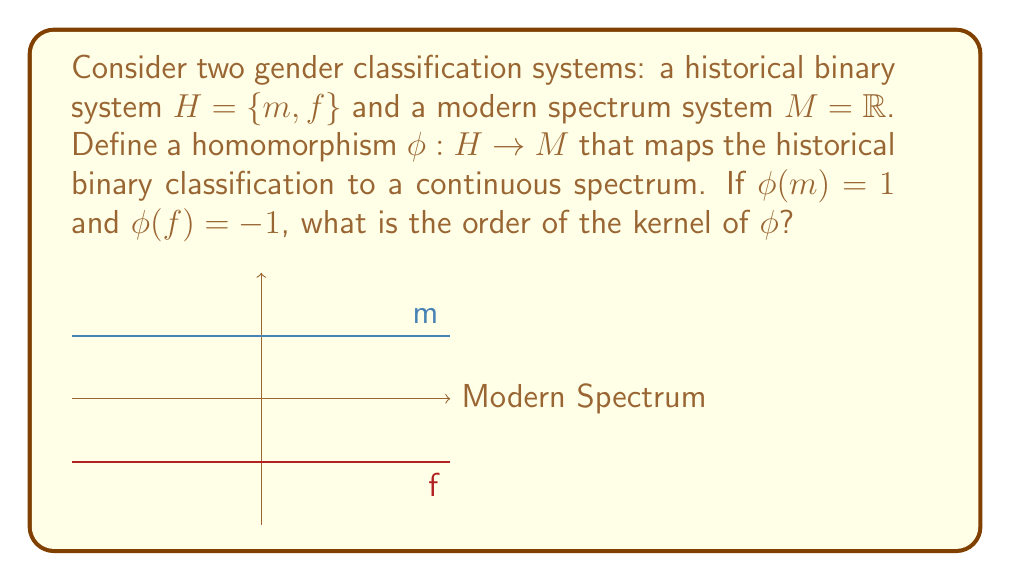Give your solution to this math problem. Let's approach this step-by-step:

1) First, recall that a homomorphism $\phi: G \rightarrow G'$ between two groups $G$ and $G'$ is a function that preserves the group operation. In this case, we're mapping from a discrete set to a continuous one.

2) The kernel of a homomorphism $\phi$ is defined as:
   $$\text{ker}(\phi) = \{x \in G : \phi(x) = e'\}$$
   where $e'$ is the identity element of the codomain group $G'$.

3) In our case, $H = \{m, f\}$ and $M = \mathbb{R}$. The identity element in $\mathbb{R}$ under addition is 0.

4) We're given that $\phi(m) = 1$ and $\phi(f) = -1$. Neither of these map to the identity element 0 in $\mathbb{R}$.

5) This means that no element in $H$ maps to the identity element in $M$ under $\phi$.

6) Therefore, $\text{ker}(\phi) = \{\}$, the empty set.

7) The order of a group (or set) is the number of elements it contains. The empty set contains no elements.
Answer: $|\text{ker}(\phi)| = 0$ 